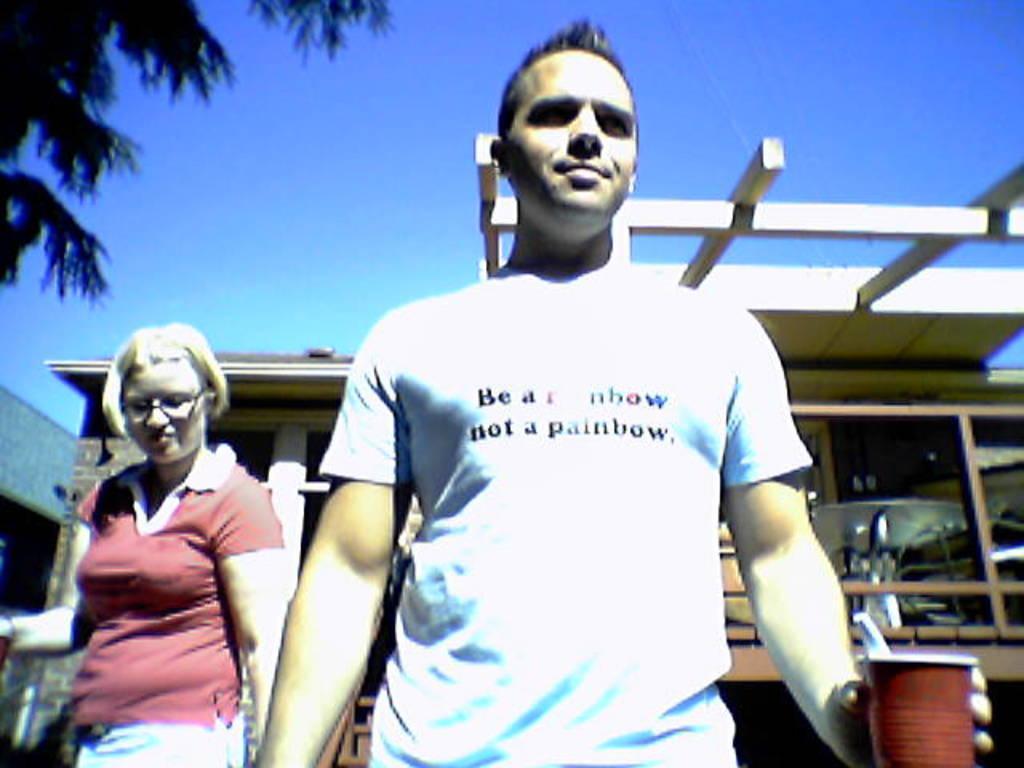Please provide a concise description of this image. This man is holding a cup. Beside this man we can see a woman. Background there is a building. Sky is in blue color. 